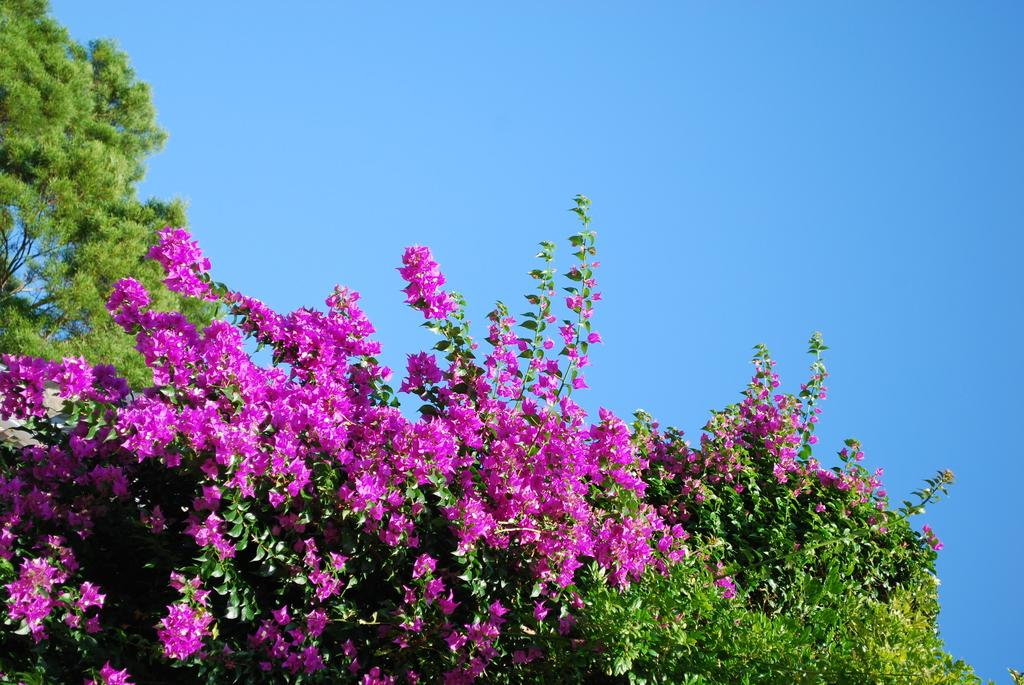What type of vegetation can be seen in the image? There are trees in the image. What other natural elements are present in the image? There are flowers in the image. What can be seen in the background of the image? The sky is visible in the background of the image. What is the tax rate for the flowers in the image? There is no tax rate mentioned or implied in the image, as it features trees, flowers, and the sky. 